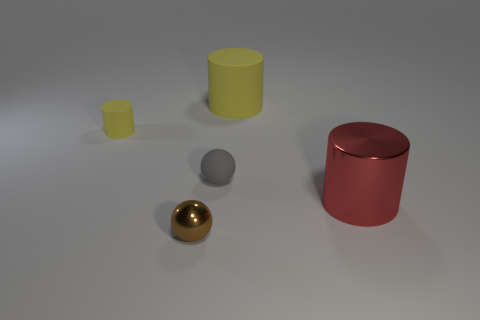Can you describe the shapes and colors of the objects in the image? Certainly! There are four objects in the image. Starting from the left, there's a small yellow cylinder, followed by a smaller yellow cube. Towards the center, we see a shiny golden sphere. Finally, on the far right, there's a larger red cylinder with a reflective surface. 